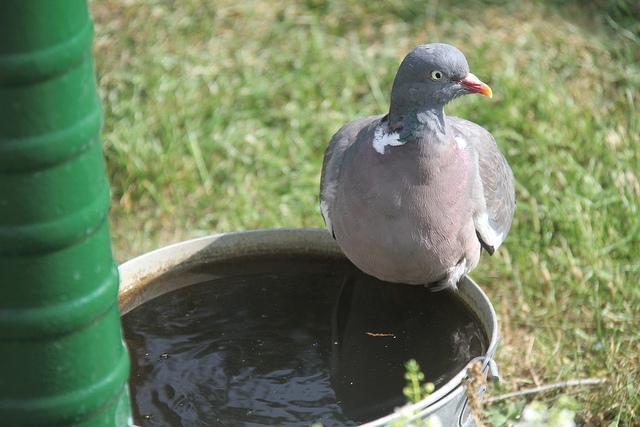How many birds are there?
Give a very brief answer. 1. How many cats?
Give a very brief answer. 0. 